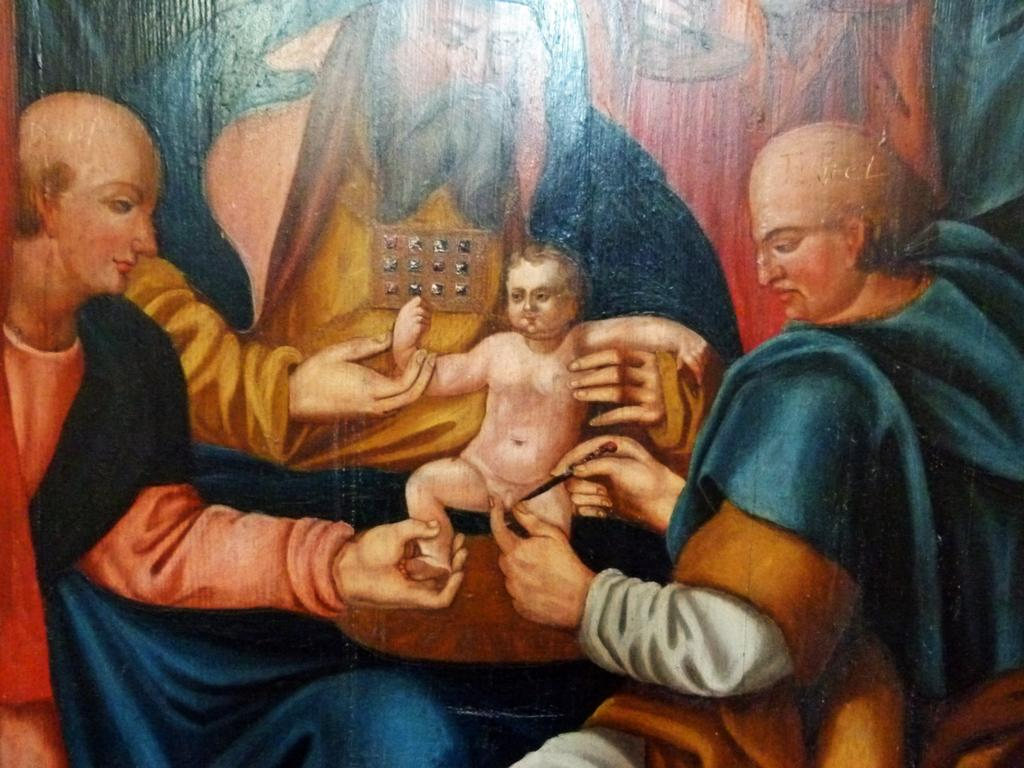What is depicted in the painting in the image? There is a painting of some persons in the image. Are there any other subjects or objects in the image besides the painting? Yes, there is a kid in the image. What type of straw is being used by the persons in the painting to write their names? There is no straw present in the painting or the image, and the persons in the painting are not shown writing their names. 